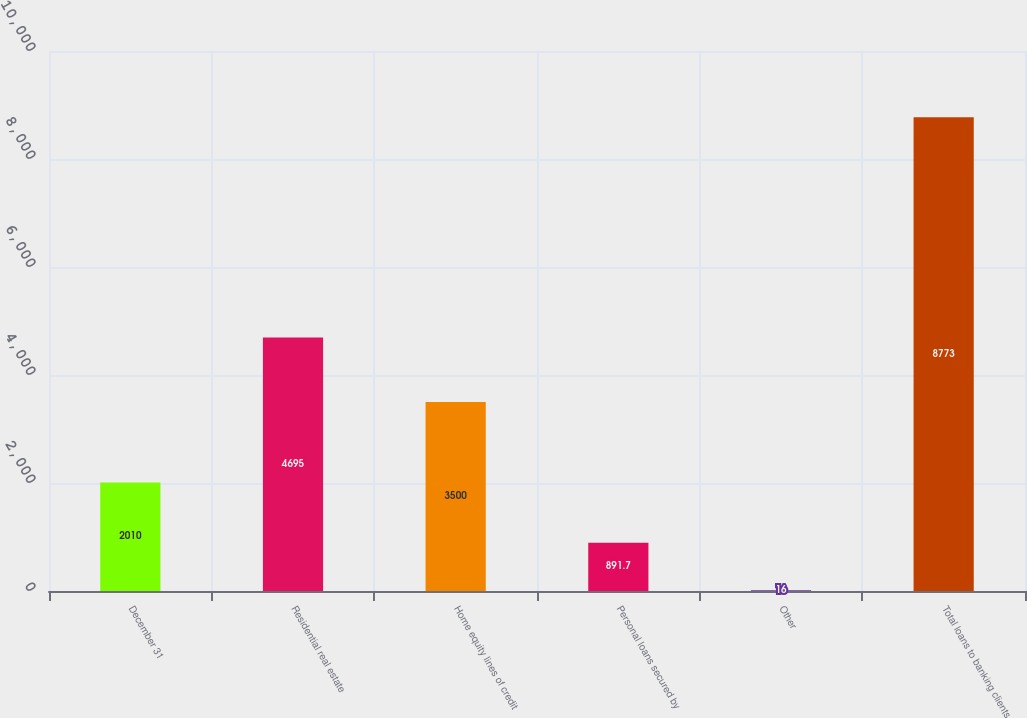Convert chart to OTSL. <chart><loc_0><loc_0><loc_500><loc_500><bar_chart><fcel>December 31<fcel>Residential real estate<fcel>Home equity lines of credit<fcel>Personal loans secured by<fcel>Other<fcel>Total loans to banking clients<nl><fcel>2010<fcel>4695<fcel>3500<fcel>891.7<fcel>16<fcel>8773<nl></chart> 